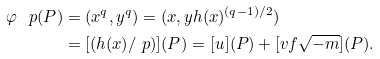Convert formula to latex. <formula><loc_0><loc_0><loc_500><loc_500>\varphi _ { \ } p ( P ) & = ( x ^ { q } , y ^ { q } ) = ( x , y h ( x ) ^ { ( q - 1 ) / 2 } ) \\ & = [ ( h ( x ) / \ p ) ] ( P ) = [ u ] ( P ) + [ v f \sqrt { - m } ] ( P ) .</formula> 